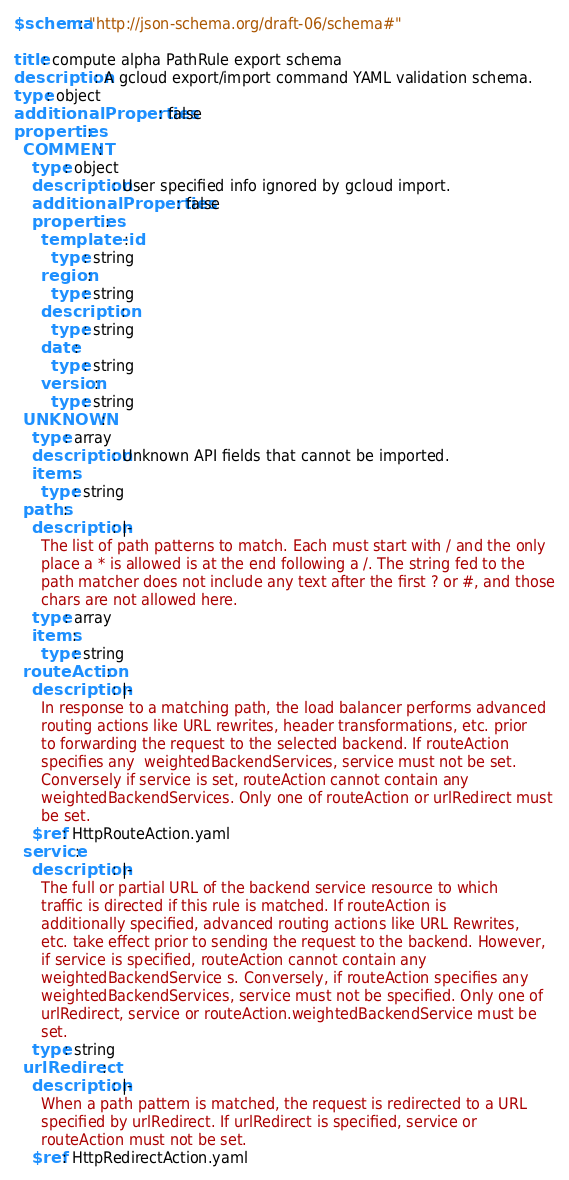Convert code to text. <code><loc_0><loc_0><loc_500><loc_500><_YAML_>$schema: "http://json-schema.org/draft-06/schema#"

title: compute alpha PathRule export schema
description: A gcloud export/import command YAML validation schema.
type: object
additionalProperties: false
properties:
  COMMENT:
    type: object
    description: User specified info ignored by gcloud import.
    additionalProperties: false
    properties:
      template-id:
        type: string
      region:
        type: string
      description:
        type: string
      date:
        type: string
      version:
        type: string
  UNKNOWN:
    type: array
    description: Unknown API fields that cannot be imported.
    items:
      type: string
  paths:
    description: |-
      The list of path patterns to match. Each must start with / and the only
      place a * is allowed is at the end following a /. The string fed to the
      path matcher does not include any text after the first ? or #, and those
      chars are not allowed here.
    type: array
    items:
      type: string
  routeAction:
    description: |-
      In response to a matching path, the load balancer performs advanced
      routing actions like URL rewrites, header transformations, etc. prior
      to forwarding the request to the selected backend. If routeAction
      specifies any  weightedBackendServices, service must not be set.
      Conversely if service is set, routeAction cannot contain any
      weightedBackendServices. Only one of routeAction or urlRedirect must
      be set.
    $ref: HttpRouteAction.yaml
  service:
    description: |-
      The full or partial URL of the backend service resource to which
      traffic is directed if this rule is matched. If routeAction is
      additionally specified, advanced routing actions like URL Rewrites,
      etc. take effect prior to sending the request to the backend. However,
      if service is specified, routeAction cannot contain any
      weightedBackendService s. Conversely, if routeAction specifies any
      weightedBackendServices, service must not be specified. Only one of
      urlRedirect, service or routeAction.weightedBackendService must be
      set.
    type: string
  urlRedirect:
    description: |-
      When a path pattern is matched, the request is redirected to a URL
      specified by urlRedirect. If urlRedirect is specified, service or
      routeAction must not be set.
    $ref: HttpRedirectAction.yaml
</code> 